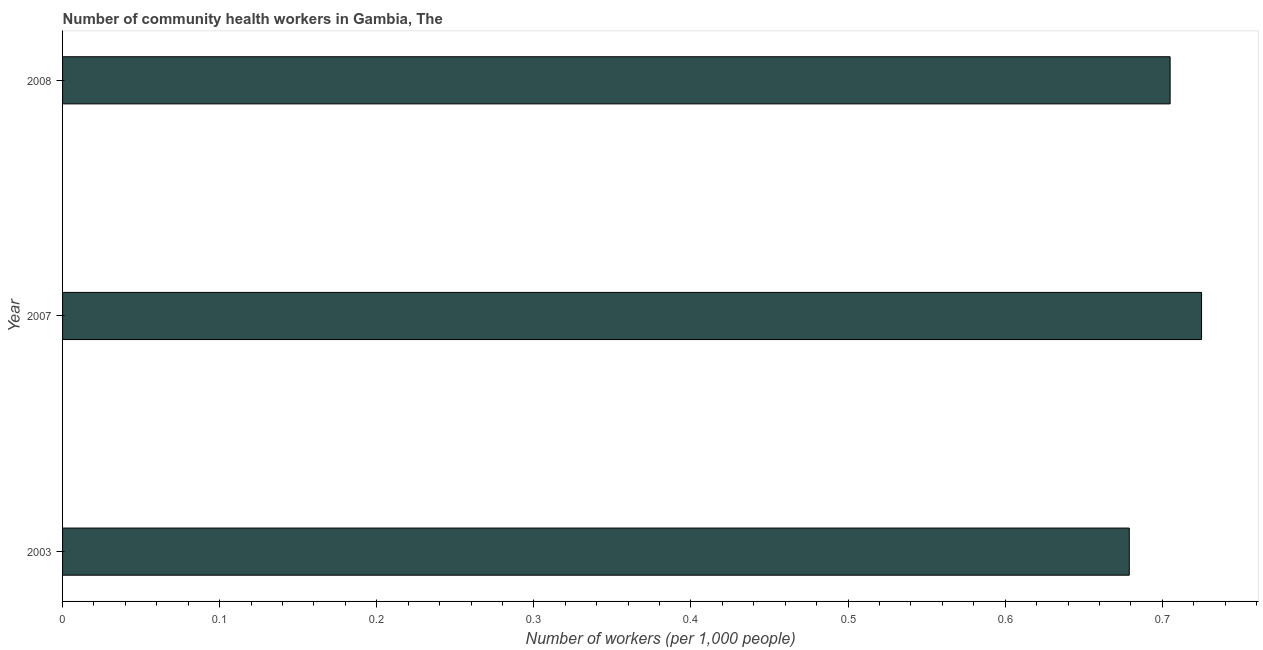Does the graph contain any zero values?
Keep it short and to the point. No. Does the graph contain grids?
Provide a short and direct response. No. What is the title of the graph?
Provide a succinct answer. Number of community health workers in Gambia, The. What is the label or title of the X-axis?
Your answer should be very brief. Number of workers (per 1,0 people). What is the number of community health workers in 2008?
Your response must be concise. 0.7. Across all years, what is the maximum number of community health workers?
Keep it short and to the point. 0.72. Across all years, what is the minimum number of community health workers?
Offer a very short reply. 0.68. What is the sum of the number of community health workers?
Give a very brief answer. 2.11. What is the difference between the number of community health workers in 2003 and 2008?
Provide a succinct answer. -0.03. What is the average number of community health workers per year?
Offer a very short reply. 0.7. What is the median number of community health workers?
Provide a short and direct response. 0.7. In how many years, is the number of community health workers greater than 0.2 ?
Your answer should be very brief. 3. What is the ratio of the number of community health workers in 2007 to that in 2008?
Your answer should be very brief. 1.03. How many bars are there?
Provide a succinct answer. 3. Are all the bars in the graph horizontal?
Your answer should be compact. Yes. How many years are there in the graph?
Offer a terse response. 3. What is the Number of workers (per 1,000 people) of 2003?
Make the answer very short. 0.68. What is the Number of workers (per 1,000 people) in 2007?
Your response must be concise. 0.72. What is the Number of workers (per 1,000 people) in 2008?
Your answer should be very brief. 0.7. What is the difference between the Number of workers (per 1,000 people) in 2003 and 2007?
Make the answer very short. -0.05. What is the difference between the Number of workers (per 1,000 people) in 2003 and 2008?
Your answer should be compact. -0.03. What is the difference between the Number of workers (per 1,000 people) in 2007 and 2008?
Provide a succinct answer. 0.02. What is the ratio of the Number of workers (per 1,000 people) in 2003 to that in 2007?
Offer a very short reply. 0.94. What is the ratio of the Number of workers (per 1,000 people) in 2007 to that in 2008?
Keep it short and to the point. 1.03. 